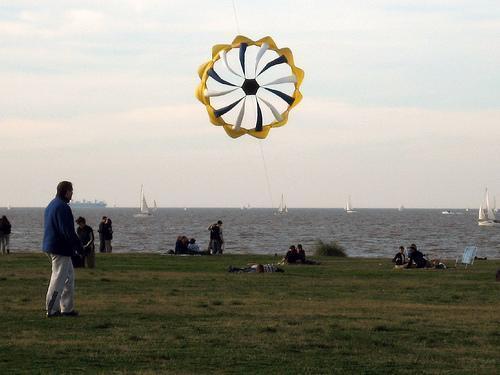The item in the sky looks most like what?
Indicate the correct response and explain using: 'Answer: answer
Rationale: rationale.'
Options: Dog, house, wheel, cat. Answer: wheel.
Rationale: It is round and has spirals that look like rims. 